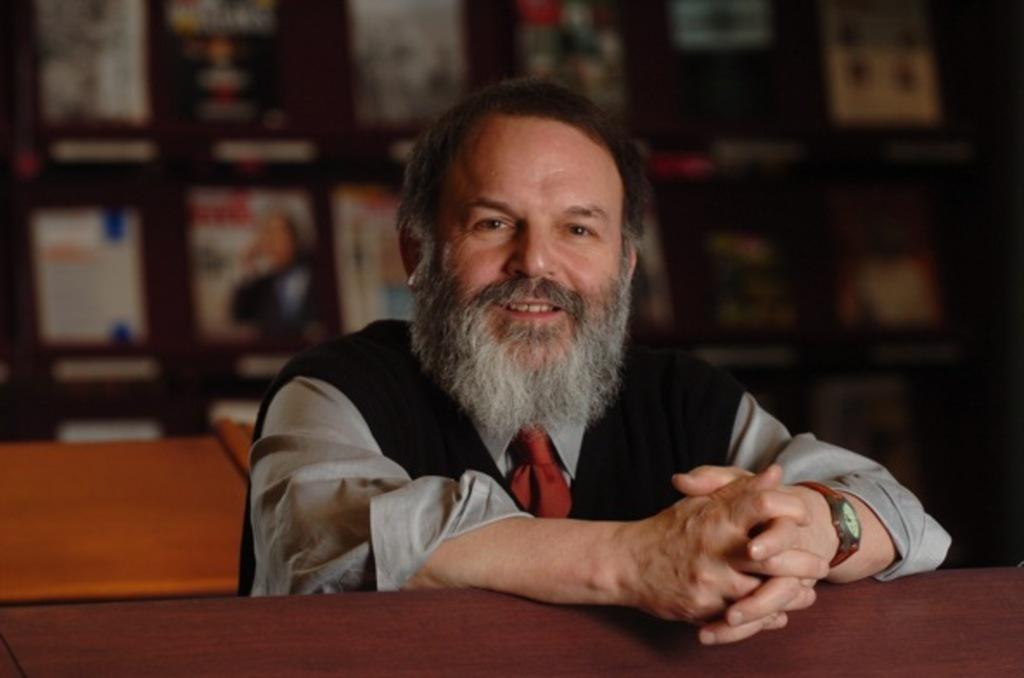Who is in the image? There is a person in the image. Can you describe the person's appearance? The person has a beard. What is the person doing in the image? The person's hands are on a table. What can be seen behind the person? There is a bookshelf behind the person. What type of bean is being used for the science experiment in the image? There is no bean or science experiment present in the image. What thrilling activity is the person participating in the image? The image does not depict any thrilling activities or indicate that the person is participating in any specific activity. 